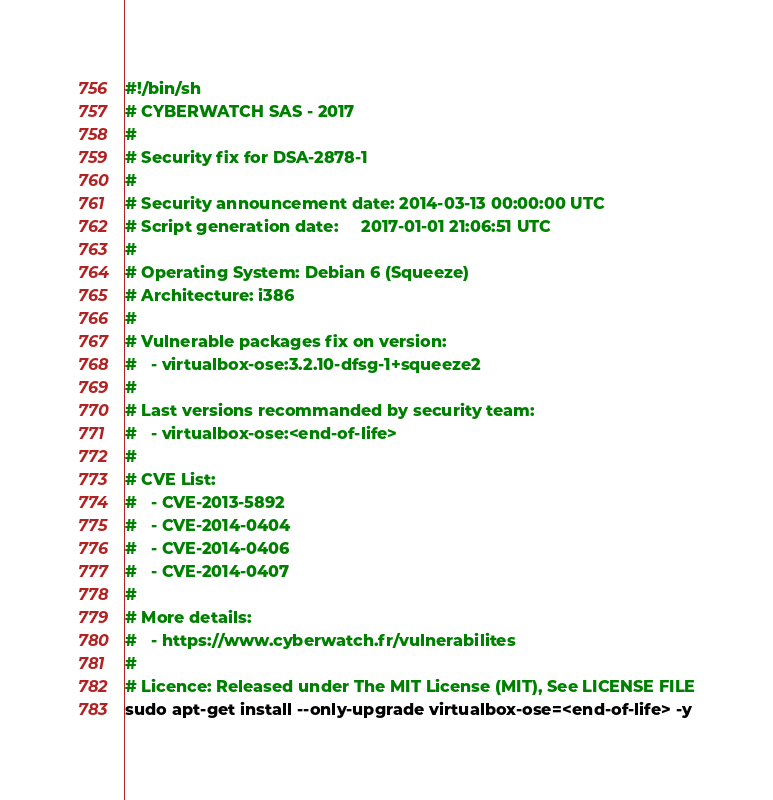Convert code to text. <code><loc_0><loc_0><loc_500><loc_500><_Bash_>#!/bin/sh
# CYBERWATCH SAS - 2017
#
# Security fix for DSA-2878-1
#
# Security announcement date: 2014-03-13 00:00:00 UTC
# Script generation date:     2017-01-01 21:06:51 UTC
#
# Operating System: Debian 6 (Squeeze)
# Architecture: i386
#
# Vulnerable packages fix on version:
#   - virtualbox-ose:3.2.10-dfsg-1+squeeze2
#
# Last versions recommanded by security team:
#   - virtualbox-ose:<end-of-life>
#
# CVE List:
#   - CVE-2013-5892
#   - CVE-2014-0404
#   - CVE-2014-0406
#   - CVE-2014-0407
#
# More details:
#   - https://www.cyberwatch.fr/vulnerabilites
#
# Licence: Released under The MIT License (MIT), See LICENSE FILE
sudo apt-get install --only-upgrade virtualbox-ose=<end-of-life> -y
</code> 